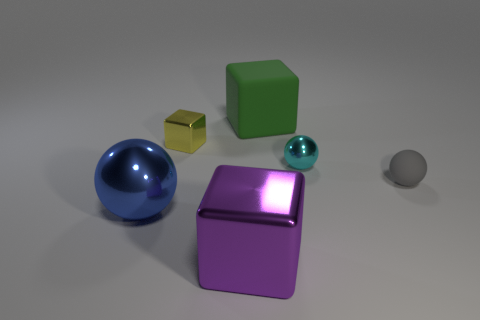There is a green cube; are there any large blue spheres behind it?
Ensure brevity in your answer.  No. Are the tiny thing that is right of the cyan shiny ball and the green object made of the same material?
Your answer should be compact. Yes. Is there a large purple block that is in front of the large metallic object that is to the left of the yellow block in front of the big green cube?
Keep it short and to the point. Yes. How many cubes are either big purple things or green objects?
Ensure brevity in your answer.  2. What is the material of the large object behind the small gray matte thing?
Keep it short and to the point. Rubber. How many things are either blue shiny objects or large cyan objects?
Give a very brief answer. 1. What number of other objects are the same shape as the purple thing?
Your response must be concise. 2. Do the large block that is behind the cyan sphere and the small object in front of the small cyan sphere have the same material?
Provide a short and direct response. Yes. There is a large thing that is both behind the purple object and in front of the tiny gray rubber sphere; what shape is it?
Your answer should be very brief. Sphere. There is a sphere that is both right of the big shiny block and in front of the cyan metallic object; what material is it?
Offer a terse response. Rubber. 